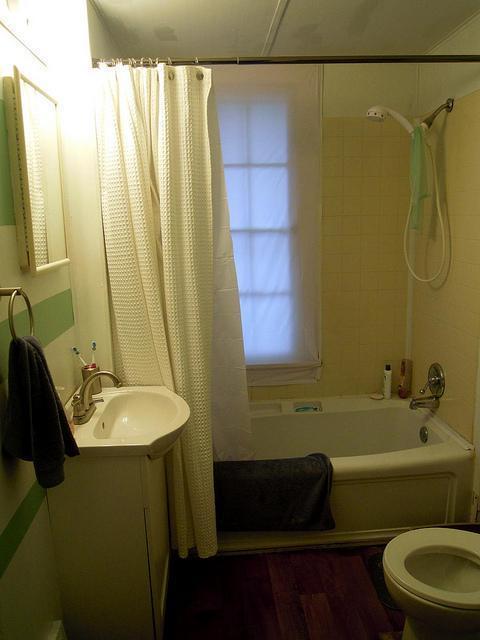What color are the stripes on the side of the bathroom wall?
Indicate the correct response by choosing from the four available options to answer the question.
Options: Blue, purple, green, pink. Green. 